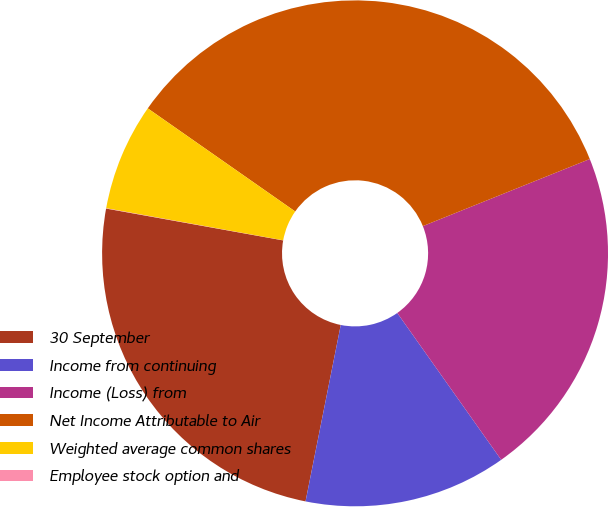Convert chart. <chart><loc_0><loc_0><loc_500><loc_500><pie_chart><fcel>30 September<fcel>Income from continuing<fcel>Income (Loss) from<fcel>Net Income Attributable to Air<fcel>Weighted average common shares<fcel>Employee stock option and<nl><fcel>24.7%<fcel>12.94%<fcel>21.28%<fcel>34.21%<fcel>6.86%<fcel>0.02%<nl></chart> 